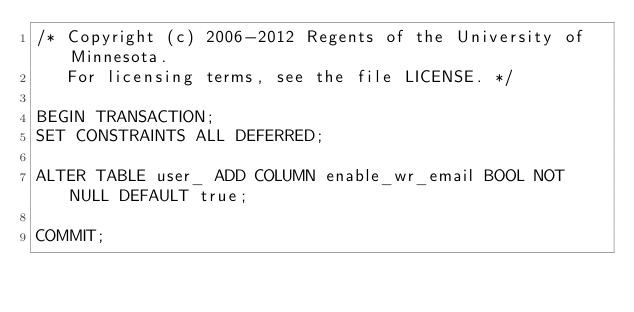<code> <loc_0><loc_0><loc_500><loc_500><_SQL_>/* Copyright (c) 2006-2012 Regents of the University of Minnesota.
   For licensing terms, see the file LICENSE. */

BEGIN TRANSACTION;
SET CONSTRAINTS ALL DEFERRED;

ALTER TABLE user_ ADD COLUMN enable_wr_email BOOL NOT NULL DEFAULT true;

COMMIT;

</code> 